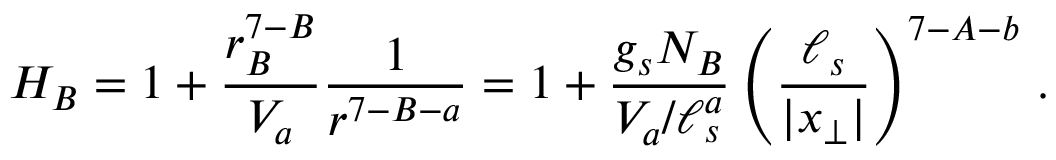<formula> <loc_0><loc_0><loc_500><loc_500>H _ { B } = 1 + { \frac { r _ { B } ^ { 7 - B } } { V _ { a } } } { \frac { 1 } { r ^ { 7 - B - a } } } = 1 + { \frac { g _ { s } N _ { B } } { V _ { a } / \ell _ { s } ^ { a } } } \left ( { \frac { \ell _ { s } } { | x _ { \perp } | } } \right ) ^ { 7 - A - b } \, .</formula> 